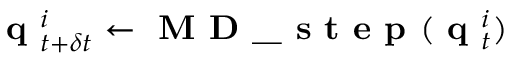<formula> <loc_0><loc_0><loc_500><loc_500>q _ { t + \delta t } ^ { i } \leftarrow M D \_ s t e p ( q _ { t } ^ { i } )</formula> 